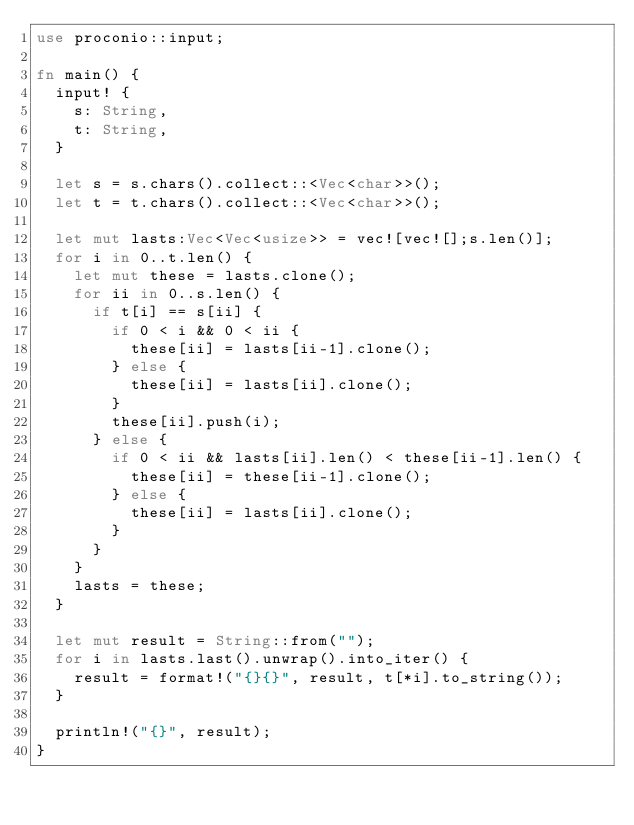Convert code to text. <code><loc_0><loc_0><loc_500><loc_500><_Rust_>use proconio::input;
 
fn main() {
  input! {
    s: String,
    t: String,
  }
  
  let s = s.chars().collect::<Vec<char>>();
  let t = t.chars().collect::<Vec<char>>();
  
  let mut lasts:Vec<Vec<usize>> = vec![vec![];s.len()];
  for i in 0..t.len() {
    let mut these = lasts.clone();
    for ii in 0..s.len() {
      if t[i] == s[ii] {
        if 0 < i && 0 < ii {
          these[ii] = lasts[ii-1].clone();
        } else {
          these[ii] = lasts[ii].clone();
        }
        these[ii].push(i);
      } else {
        if 0 < ii && lasts[ii].len() < these[ii-1].len() {
          these[ii] = these[ii-1].clone();
        } else {
          these[ii] = lasts[ii].clone();
        }
      }
    }
    lasts = these;
  }
  
  let mut result = String::from("");
  for i in lasts.last().unwrap().into_iter() {
    result = format!("{}{}", result, t[*i].to_string());
  }
 
  println!("{}", result);
}</code> 